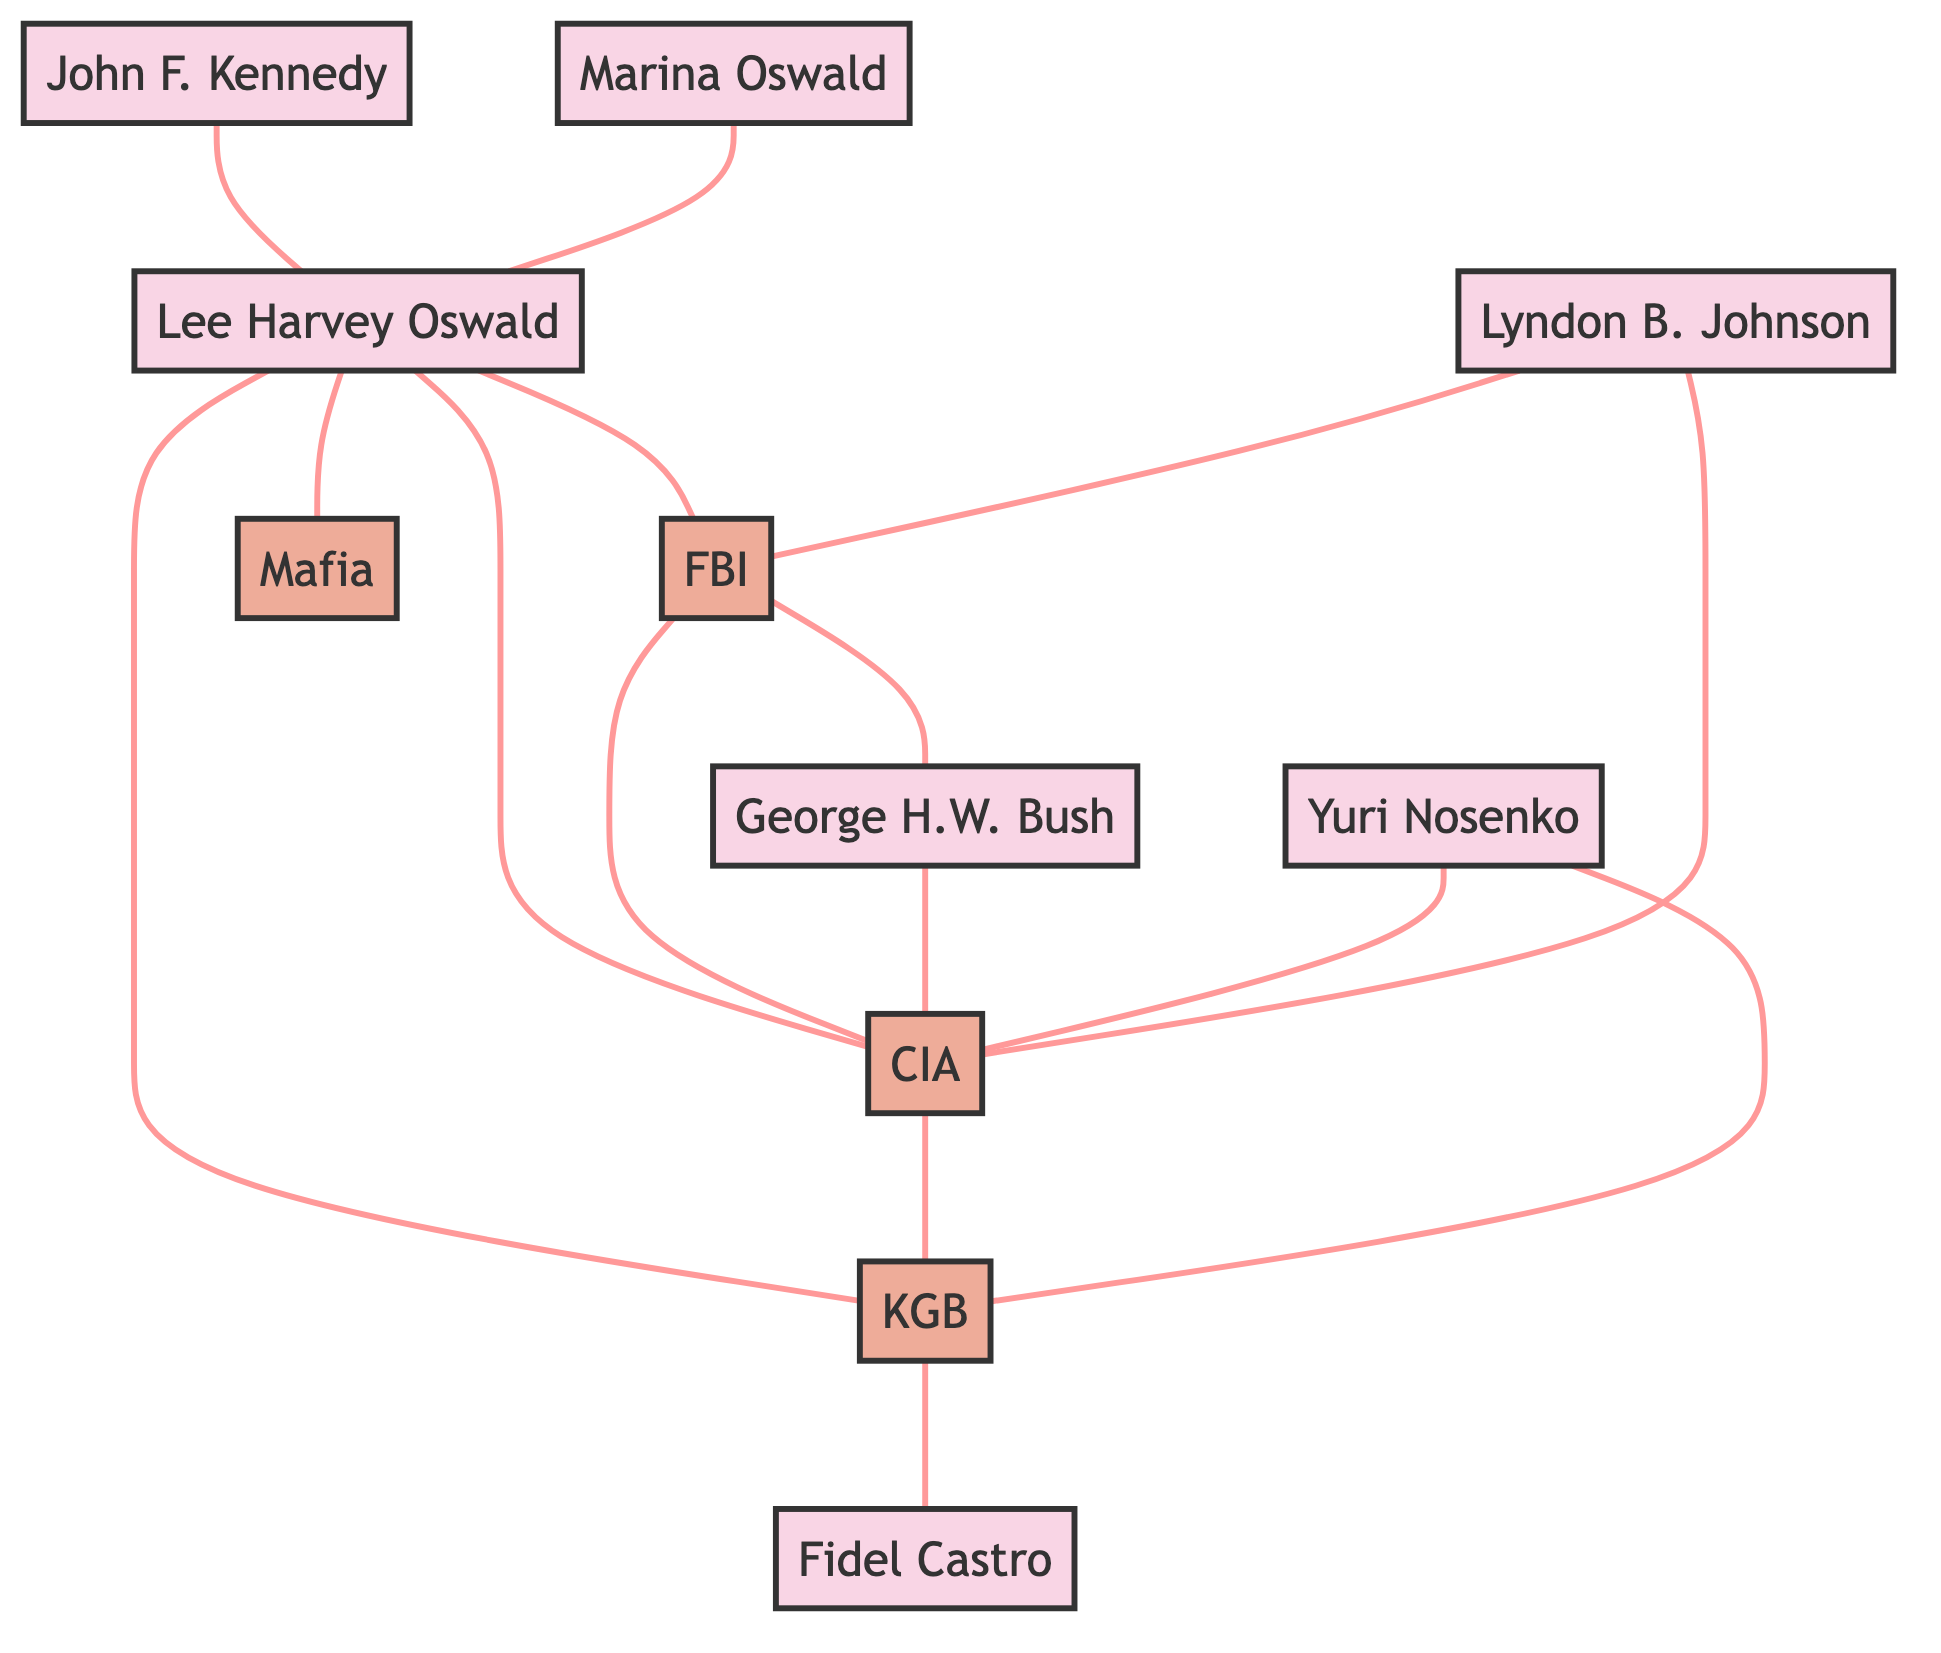What is the total number of nodes in the graph? The graph contains all unique entities such as people and organizations. By counting each one in the provided data, there are 11 nodes in total.
Answer: 11 Who is connected to Lee Harvey Oswald? The diagram indicates several connections from Lee Harvey Oswald to entities such as the FBI, CIA, KGB, Mafia, and Marina Oswald.
Answer: FBI, CIA, KGB, Mafia, Marina Oswald What organizations are connected to the FBI? This requires observing the edges connected to the FBI. The FBI has edges connecting it to the CIA and George H.W. Bush, making these the organizations connected to the FBI.
Answer: CIA, George H.W. Bush Which figure has links to both the CIA and KGB? Examining the edges, Yuri Nosenko has connections to both the CIA and KGB, making him the figure in question.
Answer: Yuri Nosenko How many edges are connected to Lee Harvey Oswald? By summarizing the connections (to FBI, CIA, KGB, Mafia, and John F. Kennedy), Lee Harvey Oswald has five edges directly connected to him in the diagram.
Answer: 5 What is the relationship between George H.W. Bush and the CIA? The diagram shows a direct edge connecting George H.W. Bush to the CIA, indicating an affiliation.
Answer: Connected Which figure is associated with both the Mafia and KGB? By analyzing the connections, there is no single figure that directly connects to both organizations. Hence, there is no answer.
Answer: None How many organizations are represented in the graph? Counting the unique organization entities listed in the data, there are four distinct organizations: FBI, CIA, KGB, and Mafia.
Answer: 4 Which two personalities are directly connected to the FBI? The diagram shows a direct connection between Lyndon B. Johnson and the FBI, as well as Lee Harvey Oswald. These are the two personalities linked to the FBI.
Answer: Lynn B. Johnson, Lee Harvey Oswald What is the only organization linked to both Lee Harvey Oswald and Yuri Nosenko? Analyzing the edges shows that the only organization linked to both individuals is the CIA, which connects to each of them.
Answer: CIA 